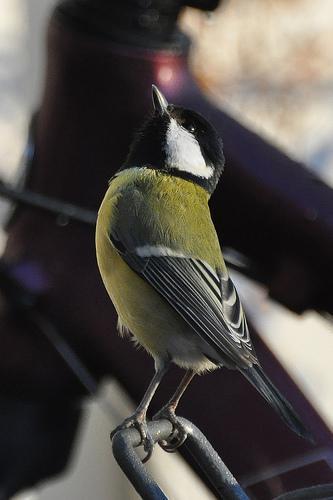How many birds are there?
Give a very brief answer. 1. 